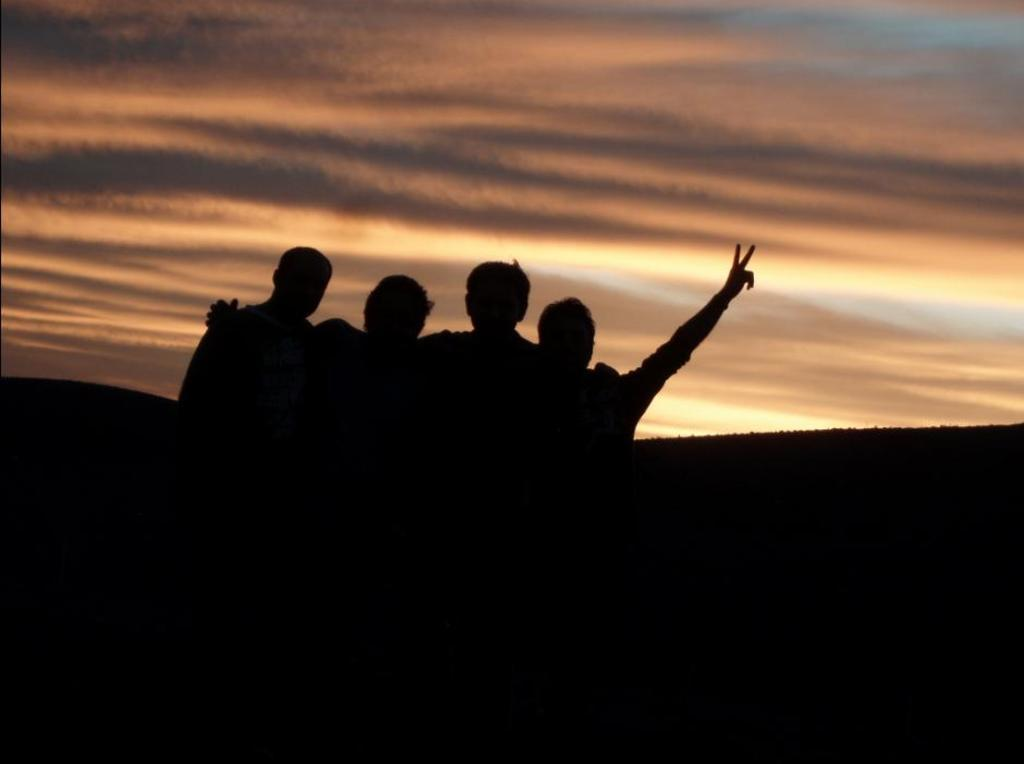What can be seen in the image? There are people standing in the image. What is visible in the background of the image? There are hills visible in the background of the image. What is visible at the top of the image? The sky is visible at the top of the image. What can be seen in the sky? Clouds are present in the sky. What type of tooth is visible in the image? There is no tooth present in the image. What material is the wool used for in the image? There is no wool or any item made of wool present in the image. 